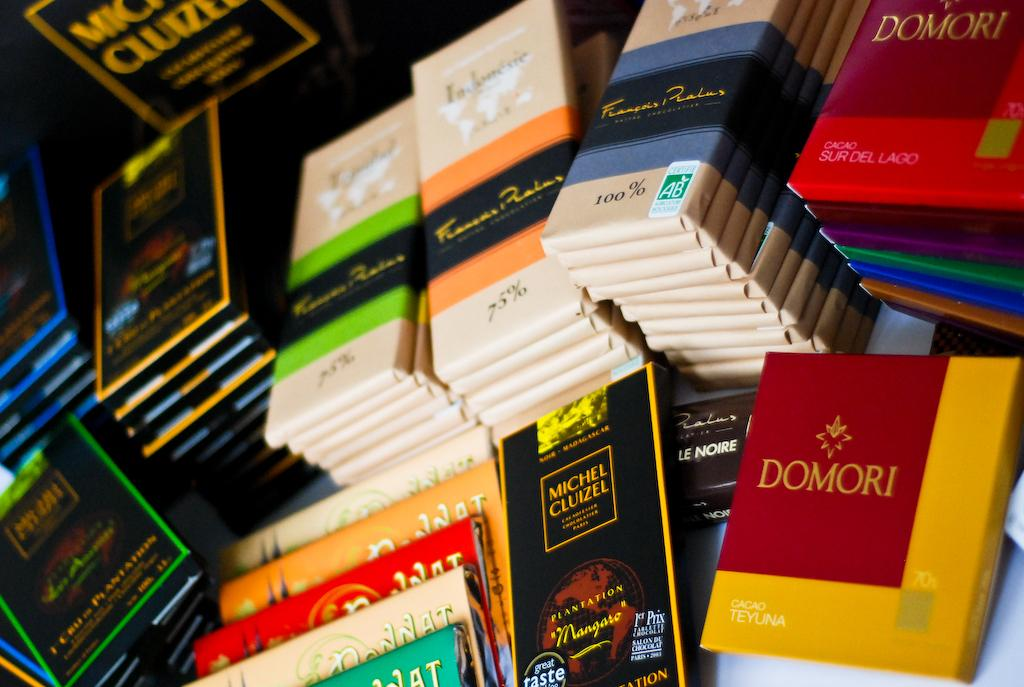What is the primary setting of the image? The primary setting of the image is a table. What can be found on the table in the image? There are objects on the table in the image. How are the objects on the table wrapped? The objects are packed in different colored wrappers. How does the quarter contribute to the activity in the image? There is no quarter present in the image, so it cannot contribute to any activity. 